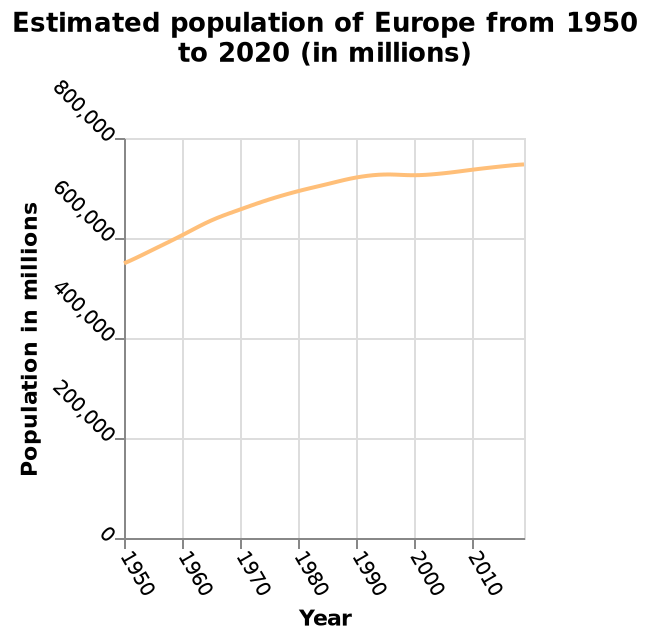<image>
What is the title of the line diagram?  The title of the line diagram is "Estimated population of Europe from 1950 to 2020 (in millions)". please describe the details of the chart This line diagram is called Estimated population of Europe from 1950 to 2020 (in millions). The y-axis plots Population in millions while the x-axis measures Year. 